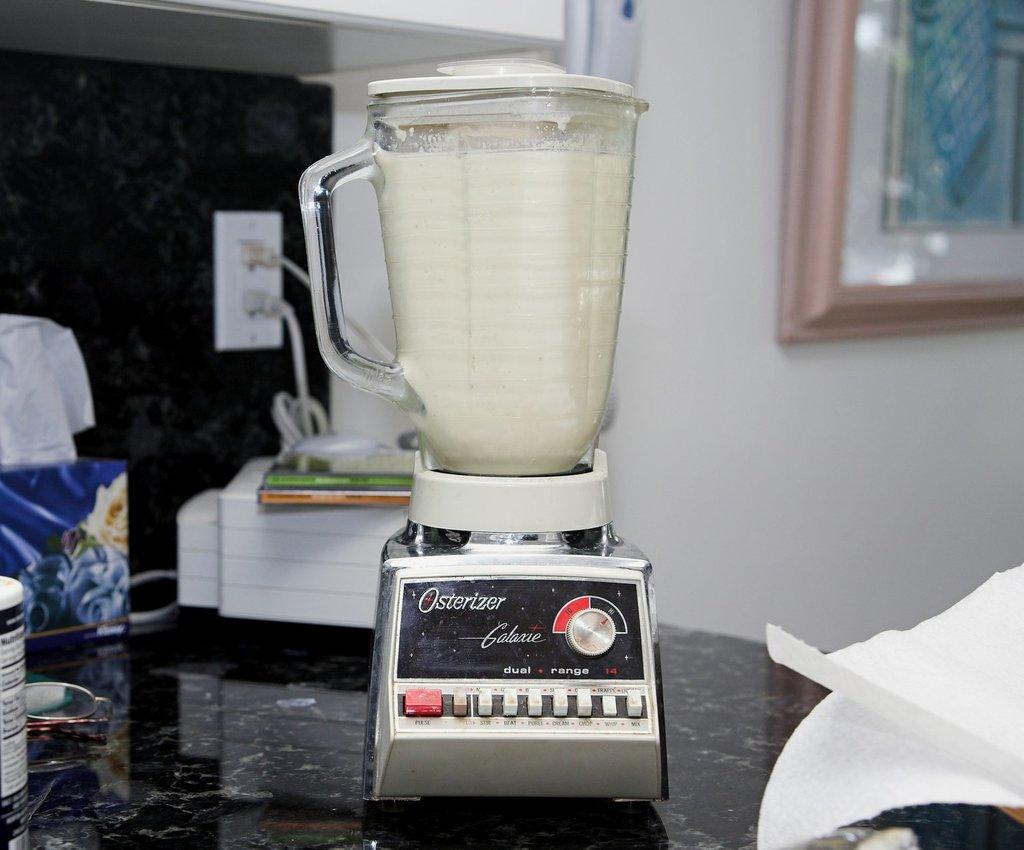What is the blender's name?
Keep it short and to the point. Osterizer. 